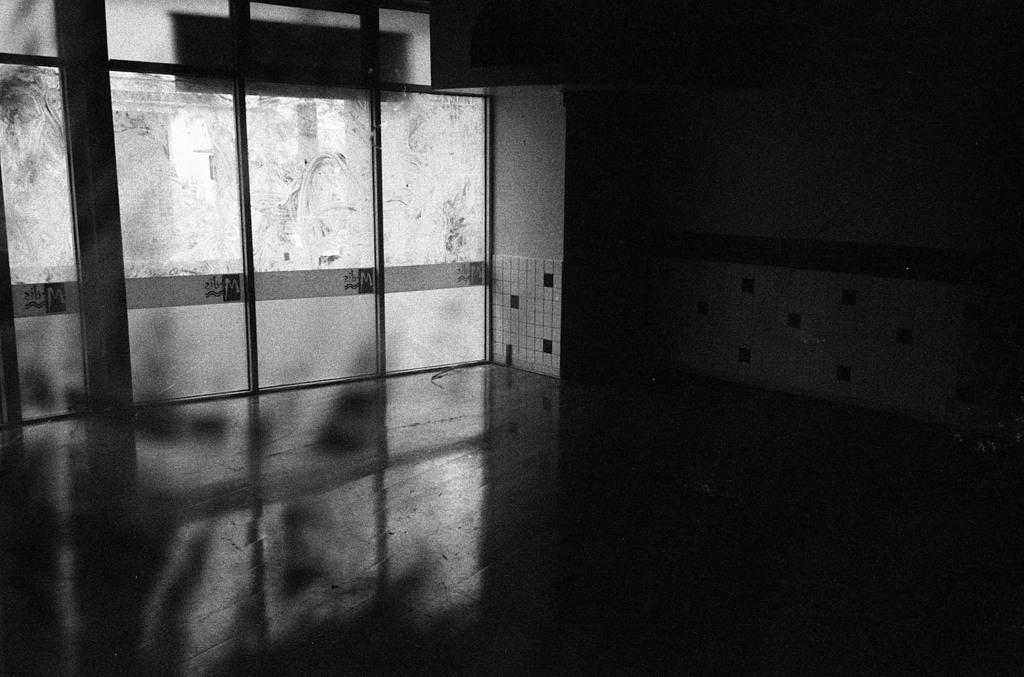What is the color scheme of the image? The image is black and white. What type of structure can be seen in the image? There is a wall in the image. What type of doors are present in the image? There are glass doors in the image. Can you see any letters floating in the sea in the image? There is no sea or letters present in the image; it features a wall and glass doors. 